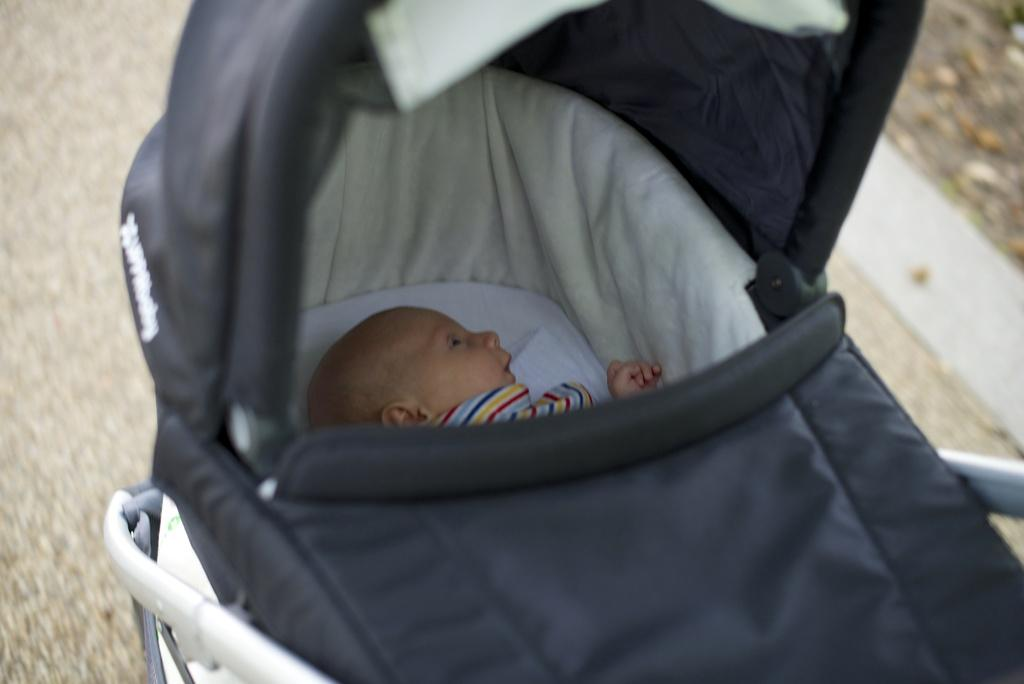What is the main subject of the image? The main subject of the image is a kid. What is the kid doing in the image? The kid is laying in a stroller. Can you describe the background of the image? The background of the image is blurry. Where is the library located in the image? There is no library present in the image. What type of servant is attending to the kid in the image? There is no servant present in the image; the kid is in a stroller. What type of fiction is the kid reading in the image? There is no book or reading material present in the image. 